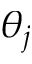<formula> <loc_0><loc_0><loc_500><loc_500>\theta _ { j }</formula> 